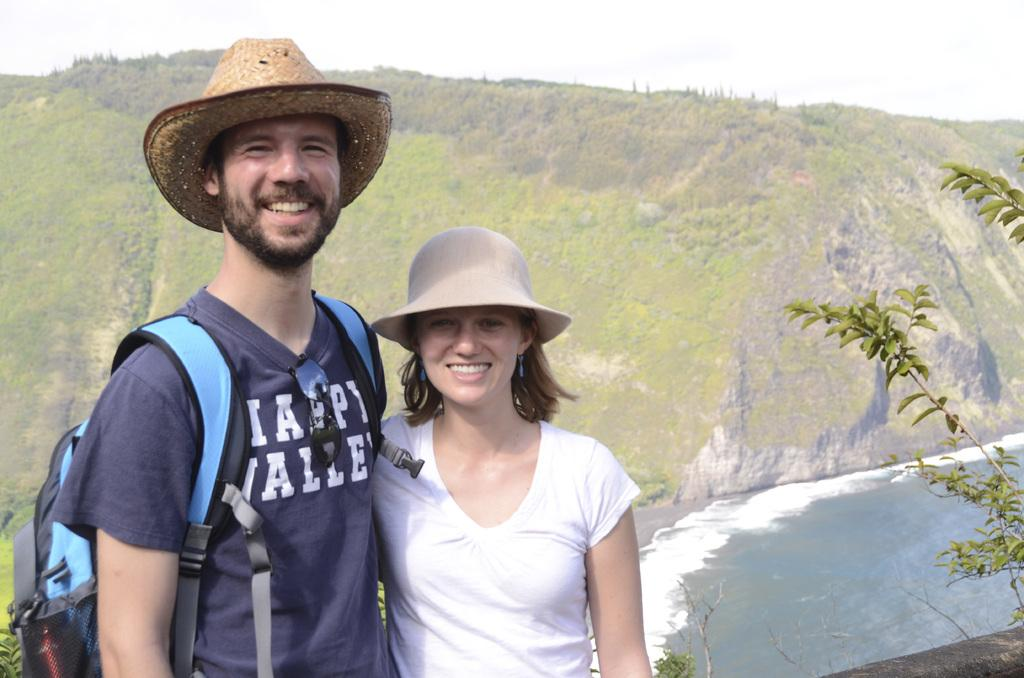<image>
Give a short and clear explanation of the subsequent image. A man, wearing a shirt saying Happy Valley, stands next to a woman. 